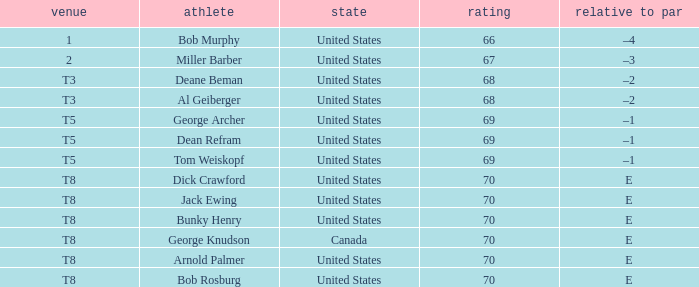When Bunky Henry of the United States scored higher than 67 and his To par was e, what was his place? T8. 